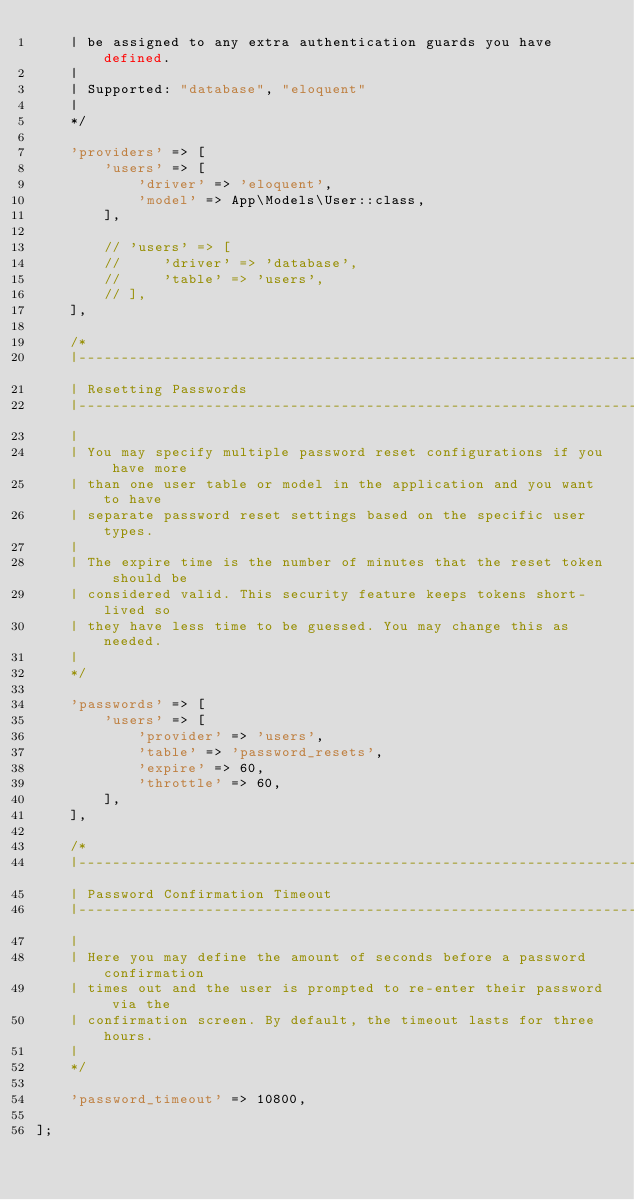Convert code to text. <code><loc_0><loc_0><loc_500><loc_500><_PHP_>    | be assigned to any extra authentication guards you have defined.
    |
    | Supported: "database", "eloquent"
    |
    */

    'providers' => [
        'users' => [
            'driver' => 'eloquent',
            'model' => App\Models\User::class,
        ],

        // 'users' => [
        //     'driver' => 'database',
        //     'table' => 'users',
        // ],
    ],

    /*
    |--------------------------------------------------------------------------
    | Resetting Passwords
    |--------------------------------------------------------------------------
    |
    | You may specify multiple password reset configurations if you have more
    | than one user table or model in the application and you want to have
    | separate password reset settings based on the specific user types.
    |
    | The expire time is the number of minutes that the reset token should be
    | considered valid. This security feature keeps tokens short-lived so
    | they have less time to be guessed. You may change this as needed.
    |
    */

    'passwords' => [
        'users' => [
            'provider' => 'users',
            'table' => 'password_resets',
            'expire' => 60,
            'throttle' => 60,
        ],
    ],

    /*
    |--------------------------------------------------------------------------
    | Password Confirmation Timeout
    |--------------------------------------------------------------------------
    |
    | Here you may define the amount of seconds before a password confirmation
    | times out and the user is prompted to re-enter their password via the
    | confirmation screen. By default, the timeout lasts for three hours.
    |
    */

    'password_timeout' => 10800,

];
</code> 